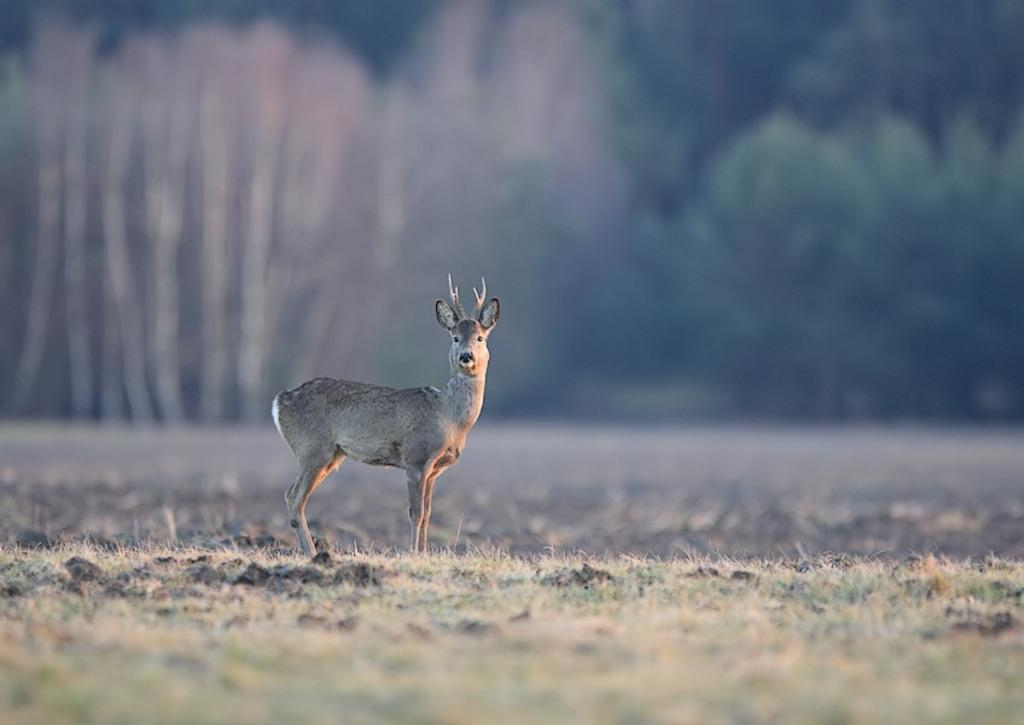What animal is present in the image? There is a white-tailed deer in the image. Where is the deer located in the image? The deer is on a path in the image. What can be seen behind the deer? There are trees behind the deer in the image. How many babies are being carried in the pail by the deer in the image? There is no pail or babies present in the image; it features a white-tailed deer on a path with trees behind it. 